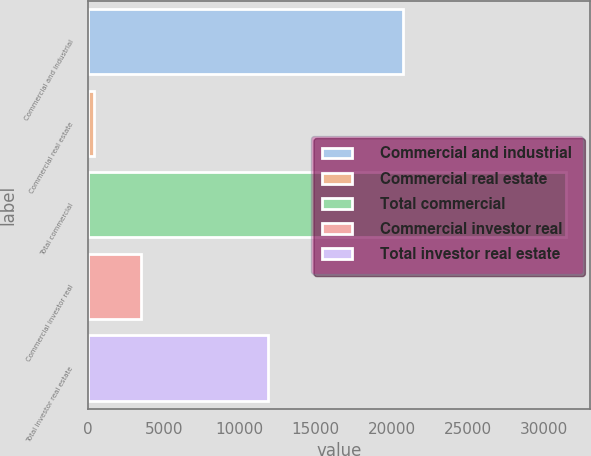Convert chart. <chart><loc_0><loc_0><loc_500><loc_500><bar_chart><fcel>Commercial and industrial<fcel>Commercial real estate<fcel>Total commercial<fcel>Commercial investor real<fcel>Total investor real estate<nl><fcel>20764<fcel>393<fcel>31501<fcel>3503.8<fcel>11865.8<nl></chart> 